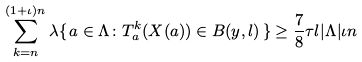<formula> <loc_0><loc_0><loc_500><loc_500>\sum _ { k = n } ^ { ( 1 + \iota ) n } \lambda \{ \, a \in \Lambda \colon T _ { a } ^ { k } ( X ( a ) ) \in B ( y , l ) \, \} \geq \frac { 7 } { 8 } \tau l | \Lambda | \iota n</formula> 